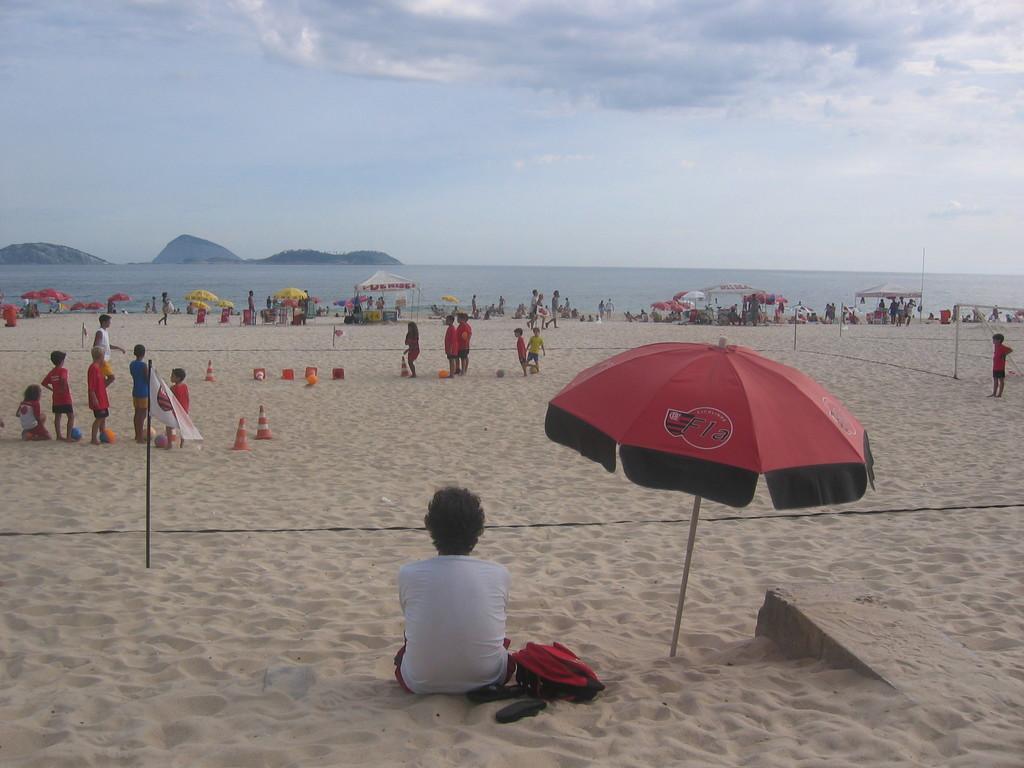How would you summarize this image in a sentence or two? This image is taken in the beach and here we can see a person sitting and there is a bag and chappell behind him. In the background, there are people standing and we can see traffic cones, tents, and hills. At the bottom, there is sand and at the top, there are clouds in the sky. 